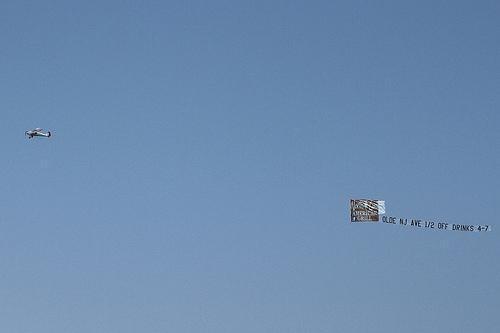How many kites are there?
Give a very brief answer. 1. 